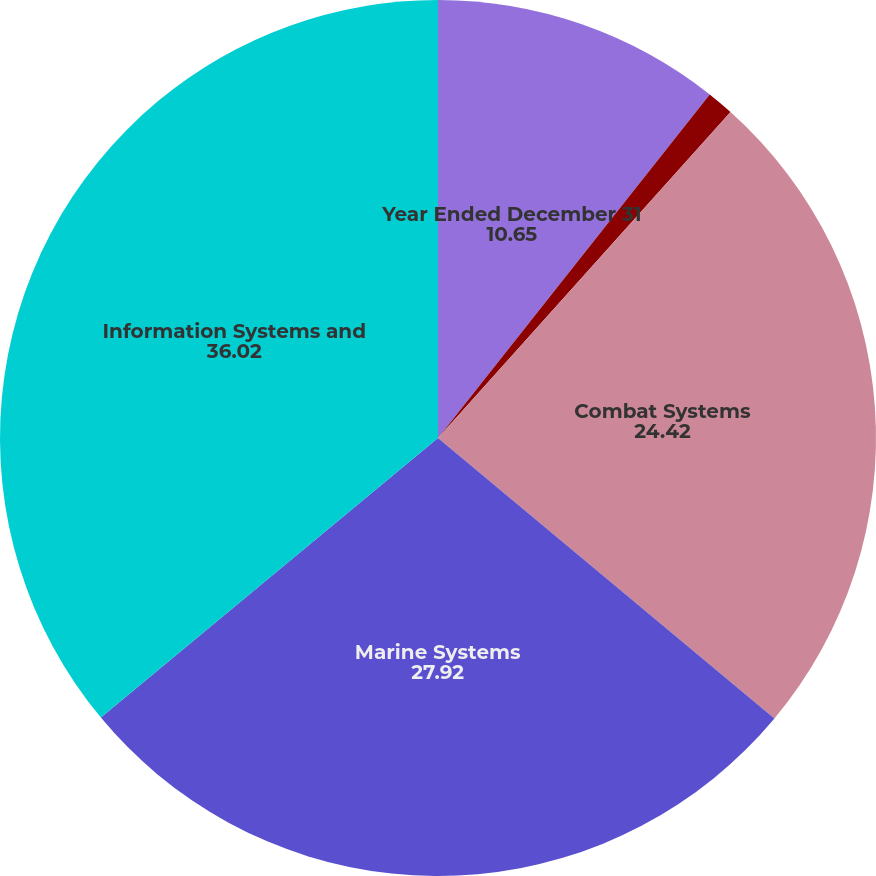<chart> <loc_0><loc_0><loc_500><loc_500><pie_chart><fcel>Year Ended December 31<fcel>Aerospace<fcel>Combat Systems<fcel>Marine Systems<fcel>Information Systems and<nl><fcel>10.65%<fcel>0.99%<fcel>24.42%<fcel>27.92%<fcel>36.02%<nl></chart> 